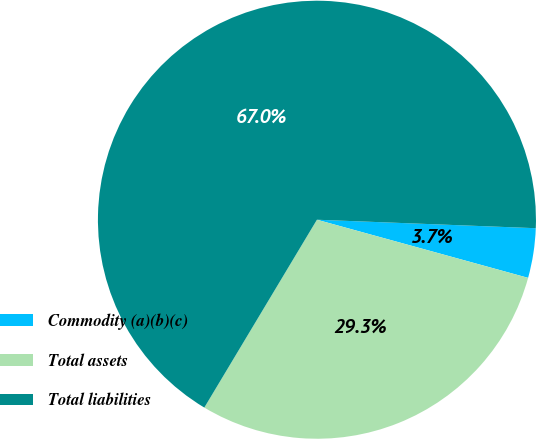Convert chart. <chart><loc_0><loc_0><loc_500><loc_500><pie_chart><fcel>Commodity (a)(b)(c)<fcel>Total assets<fcel>Total liabilities<nl><fcel>3.66%<fcel>29.32%<fcel>67.02%<nl></chart> 